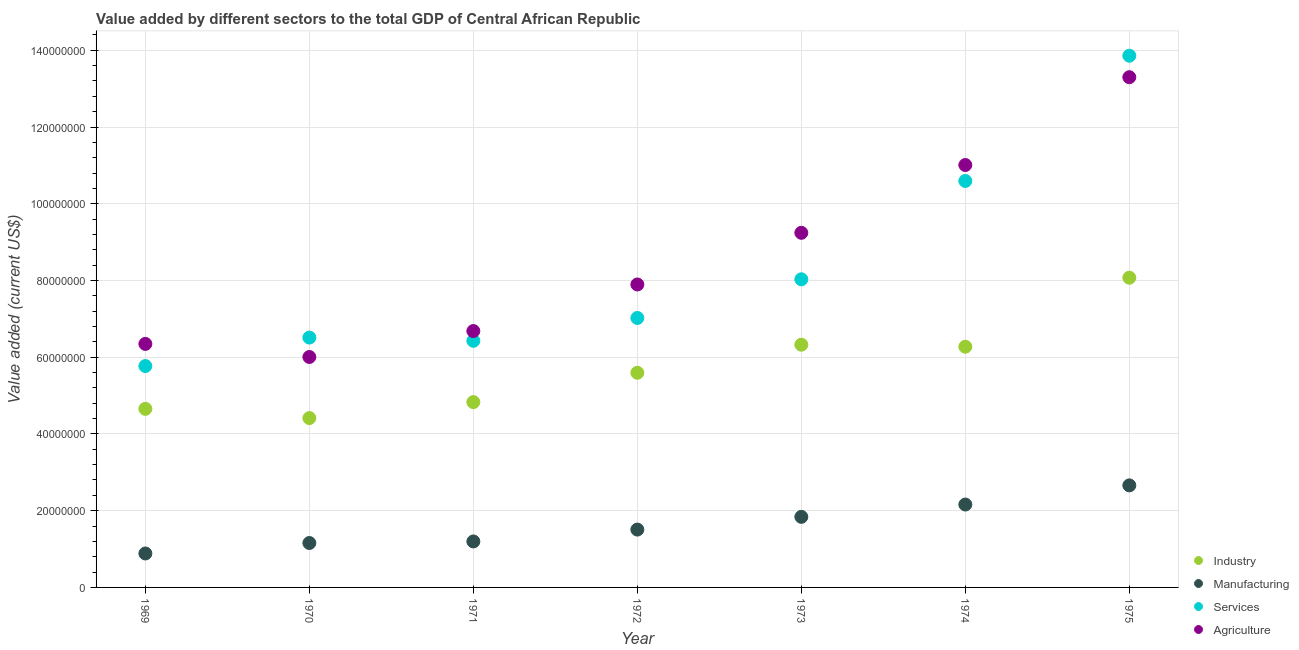How many different coloured dotlines are there?
Give a very brief answer. 4. Is the number of dotlines equal to the number of legend labels?
Ensure brevity in your answer.  Yes. What is the value added by manufacturing sector in 1969?
Your answer should be very brief. 8.85e+06. Across all years, what is the maximum value added by services sector?
Make the answer very short. 1.39e+08. Across all years, what is the minimum value added by industrial sector?
Your answer should be very brief. 4.41e+07. In which year was the value added by manufacturing sector maximum?
Offer a very short reply. 1975. In which year was the value added by services sector minimum?
Your answer should be compact. 1969. What is the total value added by agricultural sector in the graph?
Provide a short and direct response. 6.05e+08. What is the difference between the value added by services sector in 1969 and that in 1975?
Offer a terse response. -8.09e+07. What is the difference between the value added by industrial sector in 1973 and the value added by agricultural sector in 1970?
Ensure brevity in your answer.  3.20e+06. What is the average value added by services sector per year?
Provide a short and direct response. 8.32e+07. In the year 1971, what is the difference between the value added by services sector and value added by manufacturing sector?
Keep it short and to the point. 5.23e+07. In how many years, is the value added by industrial sector greater than 132000000 US$?
Ensure brevity in your answer.  0. What is the ratio of the value added by services sector in 1969 to that in 1971?
Ensure brevity in your answer.  0.9. Is the difference between the value added by agricultural sector in 1974 and 1975 greater than the difference between the value added by manufacturing sector in 1974 and 1975?
Your response must be concise. No. What is the difference between the highest and the second highest value added by manufacturing sector?
Offer a terse response. 4.99e+06. What is the difference between the highest and the lowest value added by agricultural sector?
Your answer should be compact. 7.29e+07. Is the sum of the value added by services sector in 1971 and 1972 greater than the maximum value added by industrial sector across all years?
Your answer should be compact. Yes. Is it the case that in every year, the sum of the value added by industrial sector and value added by manufacturing sector is greater than the value added by services sector?
Offer a very short reply. No. Does the value added by agricultural sector monotonically increase over the years?
Offer a terse response. No. Is the value added by industrial sector strictly greater than the value added by services sector over the years?
Your response must be concise. No. Is the value added by services sector strictly less than the value added by industrial sector over the years?
Ensure brevity in your answer.  No. What is the difference between two consecutive major ticks on the Y-axis?
Offer a very short reply. 2.00e+07. Are the values on the major ticks of Y-axis written in scientific E-notation?
Your answer should be compact. No. Does the graph contain any zero values?
Keep it short and to the point. No. How are the legend labels stacked?
Offer a very short reply. Vertical. What is the title of the graph?
Offer a terse response. Value added by different sectors to the total GDP of Central African Republic. What is the label or title of the Y-axis?
Provide a succinct answer. Value added (current US$). What is the Value added (current US$) in Industry in 1969?
Keep it short and to the point. 4.65e+07. What is the Value added (current US$) of Manufacturing in 1969?
Give a very brief answer. 8.85e+06. What is the Value added (current US$) in Services in 1969?
Give a very brief answer. 5.77e+07. What is the Value added (current US$) in Agriculture in 1969?
Make the answer very short. 6.35e+07. What is the Value added (current US$) in Industry in 1970?
Offer a terse response. 4.41e+07. What is the Value added (current US$) of Manufacturing in 1970?
Provide a short and direct response. 1.16e+07. What is the Value added (current US$) in Services in 1970?
Offer a terse response. 6.51e+07. What is the Value added (current US$) in Agriculture in 1970?
Your answer should be compact. 6.01e+07. What is the Value added (current US$) in Industry in 1971?
Your answer should be very brief. 4.83e+07. What is the Value added (current US$) in Manufacturing in 1971?
Your answer should be very brief. 1.20e+07. What is the Value added (current US$) in Services in 1971?
Provide a succinct answer. 6.43e+07. What is the Value added (current US$) of Agriculture in 1971?
Make the answer very short. 6.68e+07. What is the Value added (current US$) of Industry in 1972?
Keep it short and to the point. 5.59e+07. What is the Value added (current US$) of Manufacturing in 1972?
Make the answer very short. 1.51e+07. What is the Value added (current US$) of Services in 1972?
Provide a succinct answer. 7.02e+07. What is the Value added (current US$) in Agriculture in 1972?
Your answer should be very brief. 7.90e+07. What is the Value added (current US$) of Industry in 1973?
Make the answer very short. 6.33e+07. What is the Value added (current US$) of Manufacturing in 1973?
Offer a terse response. 1.84e+07. What is the Value added (current US$) of Services in 1973?
Your response must be concise. 8.03e+07. What is the Value added (current US$) of Agriculture in 1973?
Your answer should be compact. 9.24e+07. What is the Value added (current US$) in Industry in 1974?
Provide a short and direct response. 6.27e+07. What is the Value added (current US$) of Manufacturing in 1974?
Provide a succinct answer. 2.16e+07. What is the Value added (current US$) of Services in 1974?
Your response must be concise. 1.06e+08. What is the Value added (current US$) in Agriculture in 1974?
Your answer should be very brief. 1.10e+08. What is the Value added (current US$) of Industry in 1975?
Offer a terse response. 8.07e+07. What is the Value added (current US$) in Manufacturing in 1975?
Ensure brevity in your answer.  2.66e+07. What is the Value added (current US$) of Services in 1975?
Make the answer very short. 1.39e+08. What is the Value added (current US$) of Agriculture in 1975?
Your answer should be compact. 1.33e+08. Across all years, what is the maximum Value added (current US$) in Industry?
Offer a terse response. 8.07e+07. Across all years, what is the maximum Value added (current US$) of Manufacturing?
Provide a short and direct response. 2.66e+07. Across all years, what is the maximum Value added (current US$) of Services?
Offer a terse response. 1.39e+08. Across all years, what is the maximum Value added (current US$) in Agriculture?
Provide a succinct answer. 1.33e+08. Across all years, what is the minimum Value added (current US$) of Industry?
Provide a short and direct response. 4.41e+07. Across all years, what is the minimum Value added (current US$) of Manufacturing?
Provide a succinct answer. 8.85e+06. Across all years, what is the minimum Value added (current US$) in Services?
Offer a terse response. 5.77e+07. Across all years, what is the minimum Value added (current US$) of Agriculture?
Your answer should be compact. 6.01e+07. What is the total Value added (current US$) in Industry in the graph?
Give a very brief answer. 4.02e+08. What is the total Value added (current US$) in Manufacturing in the graph?
Provide a short and direct response. 1.14e+08. What is the total Value added (current US$) in Services in the graph?
Make the answer very short. 5.82e+08. What is the total Value added (current US$) in Agriculture in the graph?
Your answer should be very brief. 6.05e+08. What is the difference between the Value added (current US$) in Industry in 1969 and that in 1970?
Your response must be concise. 2.41e+06. What is the difference between the Value added (current US$) of Manufacturing in 1969 and that in 1970?
Your answer should be very brief. -2.73e+06. What is the difference between the Value added (current US$) in Services in 1969 and that in 1970?
Your answer should be compact. -7.42e+06. What is the difference between the Value added (current US$) of Agriculture in 1969 and that in 1970?
Keep it short and to the point. 3.41e+06. What is the difference between the Value added (current US$) of Industry in 1969 and that in 1971?
Give a very brief answer. -1.76e+06. What is the difference between the Value added (current US$) in Manufacturing in 1969 and that in 1971?
Offer a terse response. -3.14e+06. What is the difference between the Value added (current US$) in Services in 1969 and that in 1971?
Offer a terse response. -6.58e+06. What is the difference between the Value added (current US$) of Agriculture in 1969 and that in 1971?
Your answer should be compact. -3.35e+06. What is the difference between the Value added (current US$) in Industry in 1969 and that in 1972?
Make the answer very short. -9.40e+06. What is the difference between the Value added (current US$) of Manufacturing in 1969 and that in 1972?
Your answer should be very brief. -6.23e+06. What is the difference between the Value added (current US$) of Services in 1969 and that in 1972?
Your response must be concise. -1.25e+07. What is the difference between the Value added (current US$) in Agriculture in 1969 and that in 1972?
Make the answer very short. -1.55e+07. What is the difference between the Value added (current US$) in Industry in 1969 and that in 1973?
Offer a very short reply. -1.67e+07. What is the difference between the Value added (current US$) in Manufacturing in 1969 and that in 1973?
Your answer should be compact. -9.55e+06. What is the difference between the Value added (current US$) of Services in 1969 and that in 1973?
Keep it short and to the point. -2.26e+07. What is the difference between the Value added (current US$) of Agriculture in 1969 and that in 1973?
Your answer should be very brief. -2.90e+07. What is the difference between the Value added (current US$) in Industry in 1969 and that in 1974?
Keep it short and to the point. -1.62e+07. What is the difference between the Value added (current US$) of Manufacturing in 1969 and that in 1974?
Keep it short and to the point. -1.28e+07. What is the difference between the Value added (current US$) of Services in 1969 and that in 1974?
Provide a succinct answer. -4.82e+07. What is the difference between the Value added (current US$) in Agriculture in 1969 and that in 1974?
Provide a succinct answer. -4.66e+07. What is the difference between the Value added (current US$) of Industry in 1969 and that in 1975?
Give a very brief answer. -3.42e+07. What is the difference between the Value added (current US$) of Manufacturing in 1969 and that in 1975?
Ensure brevity in your answer.  -1.77e+07. What is the difference between the Value added (current US$) of Services in 1969 and that in 1975?
Your response must be concise. -8.09e+07. What is the difference between the Value added (current US$) in Agriculture in 1969 and that in 1975?
Offer a terse response. -6.95e+07. What is the difference between the Value added (current US$) in Industry in 1970 and that in 1971?
Provide a short and direct response. -4.16e+06. What is the difference between the Value added (current US$) in Manufacturing in 1970 and that in 1971?
Provide a succinct answer. -4.07e+05. What is the difference between the Value added (current US$) in Services in 1970 and that in 1971?
Your response must be concise. 8.42e+05. What is the difference between the Value added (current US$) of Agriculture in 1970 and that in 1971?
Make the answer very short. -6.77e+06. What is the difference between the Value added (current US$) in Industry in 1970 and that in 1972?
Your answer should be very brief. -1.18e+07. What is the difference between the Value added (current US$) in Manufacturing in 1970 and that in 1972?
Offer a very short reply. -3.50e+06. What is the difference between the Value added (current US$) in Services in 1970 and that in 1972?
Offer a very short reply. -5.11e+06. What is the difference between the Value added (current US$) of Agriculture in 1970 and that in 1972?
Your answer should be compact. -1.89e+07. What is the difference between the Value added (current US$) in Industry in 1970 and that in 1973?
Give a very brief answer. -1.91e+07. What is the difference between the Value added (current US$) in Manufacturing in 1970 and that in 1973?
Your answer should be very brief. -6.82e+06. What is the difference between the Value added (current US$) in Services in 1970 and that in 1973?
Keep it short and to the point. -1.52e+07. What is the difference between the Value added (current US$) in Agriculture in 1970 and that in 1973?
Provide a short and direct response. -3.24e+07. What is the difference between the Value added (current US$) of Industry in 1970 and that in 1974?
Keep it short and to the point. -1.86e+07. What is the difference between the Value added (current US$) of Manufacturing in 1970 and that in 1974?
Your response must be concise. -1.00e+07. What is the difference between the Value added (current US$) of Services in 1970 and that in 1974?
Give a very brief answer. -4.08e+07. What is the difference between the Value added (current US$) in Agriculture in 1970 and that in 1974?
Offer a terse response. -5.00e+07. What is the difference between the Value added (current US$) in Industry in 1970 and that in 1975?
Ensure brevity in your answer.  -3.66e+07. What is the difference between the Value added (current US$) in Manufacturing in 1970 and that in 1975?
Provide a short and direct response. -1.50e+07. What is the difference between the Value added (current US$) of Services in 1970 and that in 1975?
Give a very brief answer. -7.35e+07. What is the difference between the Value added (current US$) of Agriculture in 1970 and that in 1975?
Offer a very short reply. -7.29e+07. What is the difference between the Value added (current US$) of Industry in 1971 and that in 1972?
Your answer should be very brief. -7.65e+06. What is the difference between the Value added (current US$) in Manufacturing in 1971 and that in 1972?
Offer a terse response. -3.09e+06. What is the difference between the Value added (current US$) of Services in 1971 and that in 1972?
Make the answer very short. -5.95e+06. What is the difference between the Value added (current US$) of Agriculture in 1971 and that in 1972?
Ensure brevity in your answer.  -1.21e+07. What is the difference between the Value added (current US$) of Industry in 1971 and that in 1973?
Provide a short and direct response. -1.50e+07. What is the difference between the Value added (current US$) of Manufacturing in 1971 and that in 1973?
Give a very brief answer. -6.41e+06. What is the difference between the Value added (current US$) in Services in 1971 and that in 1973?
Offer a terse response. -1.60e+07. What is the difference between the Value added (current US$) of Agriculture in 1971 and that in 1973?
Offer a terse response. -2.56e+07. What is the difference between the Value added (current US$) of Industry in 1971 and that in 1974?
Offer a terse response. -1.44e+07. What is the difference between the Value added (current US$) in Manufacturing in 1971 and that in 1974?
Your answer should be very brief. -9.62e+06. What is the difference between the Value added (current US$) of Services in 1971 and that in 1974?
Make the answer very short. -4.17e+07. What is the difference between the Value added (current US$) of Agriculture in 1971 and that in 1974?
Your response must be concise. -4.33e+07. What is the difference between the Value added (current US$) in Industry in 1971 and that in 1975?
Make the answer very short. -3.24e+07. What is the difference between the Value added (current US$) in Manufacturing in 1971 and that in 1975?
Your answer should be compact. -1.46e+07. What is the difference between the Value added (current US$) of Services in 1971 and that in 1975?
Your response must be concise. -7.43e+07. What is the difference between the Value added (current US$) of Agriculture in 1971 and that in 1975?
Offer a very short reply. -6.62e+07. What is the difference between the Value added (current US$) in Industry in 1972 and that in 1973?
Make the answer very short. -7.31e+06. What is the difference between the Value added (current US$) of Manufacturing in 1972 and that in 1973?
Give a very brief answer. -3.32e+06. What is the difference between the Value added (current US$) of Services in 1972 and that in 1973?
Make the answer very short. -1.01e+07. What is the difference between the Value added (current US$) in Agriculture in 1972 and that in 1973?
Provide a succinct answer. -1.35e+07. What is the difference between the Value added (current US$) of Industry in 1972 and that in 1974?
Offer a terse response. -6.79e+06. What is the difference between the Value added (current US$) of Manufacturing in 1972 and that in 1974?
Give a very brief answer. -6.53e+06. What is the difference between the Value added (current US$) of Services in 1972 and that in 1974?
Keep it short and to the point. -3.57e+07. What is the difference between the Value added (current US$) of Agriculture in 1972 and that in 1974?
Provide a succinct answer. -3.11e+07. What is the difference between the Value added (current US$) in Industry in 1972 and that in 1975?
Your answer should be compact. -2.48e+07. What is the difference between the Value added (current US$) of Manufacturing in 1972 and that in 1975?
Ensure brevity in your answer.  -1.15e+07. What is the difference between the Value added (current US$) in Services in 1972 and that in 1975?
Give a very brief answer. -6.84e+07. What is the difference between the Value added (current US$) in Agriculture in 1972 and that in 1975?
Give a very brief answer. -5.40e+07. What is the difference between the Value added (current US$) in Industry in 1973 and that in 1974?
Your response must be concise. 5.28e+05. What is the difference between the Value added (current US$) in Manufacturing in 1973 and that in 1974?
Make the answer very short. -3.21e+06. What is the difference between the Value added (current US$) in Services in 1973 and that in 1974?
Your response must be concise. -2.56e+07. What is the difference between the Value added (current US$) of Agriculture in 1973 and that in 1974?
Make the answer very short. -1.77e+07. What is the difference between the Value added (current US$) of Industry in 1973 and that in 1975?
Your answer should be very brief. -1.75e+07. What is the difference between the Value added (current US$) of Manufacturing in 1973 and that in 1975?
Give a very brief answer. -8.20e+06. What is the difference between the Value added (current US$) in Services in 1973 and that in 1975?
Offer a terse response. -5.83e+07. What is the difference between the Value added (current US$) in Agriculture in 1973 and that in 1975?
Offer a very short reply. -4.06e+07. What is the difference between the Value added (current US$) in Industry in 1974 and that in 1975?
Provide a short and direct response. -1.80e+07. What is the difference between the Value added (current US$) of Manufacturing in 1974 and that in 1975?
Provide a short and direct response. -4.99e+06. What is the difference between the Value added (current US$) of Services in 1974 and that in 1975?
Provide a short and direct response. -3.26e+07. What is the difference between the Value added (current US$) in Agriculture in 1974 and that in 1975?
Your answer should be very brief. -2.29e+07. What is the difference between the Value added (current US$) in Industry in 1969 and the Value added (current US$) in Manufacturing in 1970?
Provide a succinct answer. 3.50e+07. What is the difference between the Value added (current US$) in Industry in 1969 and the Value added (current US$) in Services in 1970?
Provide a succinct answer. -1.86e+07. What is the difference between the Value added (current US$) in Industry in 1969 and the Value added (current US$) in Agriculture in 1970?
Offer a terse response. -1.35e+07. What is the difference between the Value added (current US$) of Manufacturing in 1969 and the Value added (current US$) of Services in 1970?
Your response must be concise. -5.63e+07. What is the difference between the Value added (current US$) of Manufacturing in 1969 and the Value added (current US$) of Agriculture in 1970?
Ensure brevity in your answer.  -5.12e+07. What is the difference between the Value added (current US$) in Services in 1969 and the Value added (current US$) in Agriculture in 1970?
Your answer should be compact. -2.36e+06. What is the difference between the Value added (current US$) of Industry in 1969 and the Value added (current US$) of Manufacturing in 1971?
Offer a very short reply. 3.46e+07. What is the difference between the Value added (current US$) of Industry in 1969 and the Value added (current US$) of Services in 1971?
Provide a short and direct response. -1.77e+07. What is the difference between the Value added (current US$) in Industry in 1969 and the Value added (current US$) in Agriculture in 1971?
Make the answer very short. -2.03e+07. What is the difference between the Value added (current US$) in Manufacturing in 1969 and the Value added (current US$) in Services in 1971?
Give a very brief answer. -5.54e+07. What is the difference between the Value added (current US$) of Manufacturing in 1969 and the Value added (current US$) of Agriculture in 1971?
Your answer should be very brief. -5.80e+07. What is the difference between the Value added (current US$) in Services in 1969 and the Value added (current US$) in Agriculture in 1971?
Provide a short and direct response. -9.12e+06. What is the difference between the Value added (current US$) of Industry in 1969 and the Value added (current US$) of Manufacturing in 1972?
Offer a terse response. 3.15e+07. What is the difference between the Value added (current US$) of Industry in 1969 and the Value added (current US$) of Services in 1972?
Your response must be concise. -2.37e+07. What is the difference between the Value added (current US$) of Industry in 1969 and the Value added (current US$) of Agriculture in 1972?
Keep it short and to the point. -3.24e+07. What is the difference between the Value added (current US$) in Manufacturing in 1969 and the Value added (current US$) in Services in 1972?
Make the answer very short. -6.14e+07. What is the difference between the Value added (current US$) in Manufacturing in 1969 and the Value added (current US$) in Agriculture in 1972?
Your response must be concise. -7.01e+07. What is the difference between the Value added (current US$) of Services in 1969 and the Value added (current US$) of Agriculture in 1972?
Your answer should be compact. -2.13e+07. What is the difference between the Value added (current US$) of Industry in 1969 and the Value added (current US$) of Manufacturing in 1973?
Your answer should be very brief. 2.82e+07. What is the difference between the Value added (current US$) of Industry in 1969 and the Value added (current US$) of Services in 1973?
Keep it short and to the point. -3.38e+07. What is the difference between the Value added (current US$) in Industry in 1969 and the Value added (current US$) in Agriculture in 1973?
Give a very brief answer. -4.59e+07. What is the difference between the Value added (current US$) in Manufacturing in 1969 and the Value added (current US$) in Services in 1973?
Make the answer very short. -7.15e+07. What is the difference between the Value added (current US$) of Manufacturing in 1969 and the Value added (current US$) of Agriculture in 1973?
Offer a terse response. -8.36e+07. What is the difference between the Value added (current US$) of Services in 1969 and the Value added (current US$) of Agriculture in 1973?
Your response must be concise. -3.47e+07. What is the difference between the Value added (current US$) in Industry in 1969 and the Value added (current US$) in Manufacturing in 1974?
Keep it short and to the point. 2.49e+07. What is the difference between the Value added (current US$) in Industry in 1969 and the Value added (current US$) in Services in 1974?
Make the answer very short. -5.94e+07. What is the difference between the Value added (current US$) in Industry in 1969 and the Value added (current US$) in Agriculture in 1974?
Make the answer very short. -6.35e+07. What is the difference between the Value added (current US$) in Manufacturing in 1969 and the Value added (current US$) in Services in 1974?
Keep it short and to the point. -9.71e+07. What is the difference between the Value added (current US$) in Manufacturing in 1969 and the Value added (current US$) in Agriculture in 1974?
Offer a very short reply. -1.01e+08. What is the difference between the Value added (current US$) in Services in 1969 and the Value added (current US$) in Agriculture in 1974?
Make the answer very short. -5.24e+07. What is the difference between the Value added (current US$) in Industry in 1969 and the Value added (current US$) in Manufacturing in 1975?
Offer a terse response. 1.99e+07. What is the difference between the Value added (current US$) in Industry in 1969 and the Value added (current US$) in Services in 1975?
Make the answer very short. -9.20e+07. What is the difference between the Value added (current US$) of Industry in 1969 and the Value added (current US$) of Agriculture in 1975?
Your answer should be compact. -8.64e+07. What is the difference between the Value added (current US$) in Manufacturing in 1969 and the Value added (current US$) in Services in 1975?
Ensure brevity in your answer.  -1.30e+08. What is the difference between the Value added (current US$) of Manufacturing in 1969 and the Value added (current US$) of Agriculture in 1975?
Ensure brevity in your answer.  -1.24e+08. What is the difference between the Value added (current US$) of Services in 1969 and the Value added (current US$) of Agriculture in 1975?
Your answer should be very brief. -7.53e+07. What is the difference between the Value added (current US$) of Industry in 1970 and the Value added (current US$) of Manufacturing in 1971?
Keep it short and to the point. 3.22e+07. What is the difference between the Value added (current US$) in Industry in 1970 and the Value added (current US$) in Services in 1971?
Give a very brief answer. -2.01e+07. What is the difference between the Value added (current US$) of Industry in 1970 and the Value added (current US$) of Agriculture in 1971?
Give a very brief answer. -2.27e+07. What is the difference between the Value added (current US$) of Manufacturing in 1970 and the Value added (current US$) of Services in 1971?
Ensure brevity in your answer.  -5.27e+07. What is the difference between the Value added (current US$) in Manufacturing in 1970 and the Value added (current US$) in Agriculture in 1971?
Make the answer very short. -5.52e+07. What is the difference between the Value added (current US$) of Services in 1970 and the Value added (current US$) of Agriculture in 1971?
Keep it short and to the point. -1.70e+06. What is the difference between the Value added (current US$) in Industry in 1970 and the Value added (current US$) in Manufacturing in 1972?
Provide a succinct answer. 2.91e+07. What is the difference between the Value added (current US$) in Industry in 1970 and the Value added (current US$) in Services in 1972?
Your answer should be compact. -2.61e+07. What is the difference between the Value added (current US$) in Industry in 1970 and the Value added (current US$) in Agriculture in 1972?
Your answer should be compact. -3.48e+07. What is the difference between the Value added (current US$) of Manufacturing in 1970 and the Value added (current US$) of Services in 1972?
Your response must be concise. -5.87e+07. What is the difference between the Value added (current US$) of Manufacturing in 1970 and the Value added (current US$) of Agriculture in 1972?
Keep it short and to the point. -6.74e+07. What is the difference between the Value added (current US$) in Services in 1970 and the Value added (current US$) in Agriculture in 1972?
Provide a succinct answer. -1.38e+07. What is the difference between the Value added (current US$) in Industry in 1970 and the Value added (current US$) in Manufacturing in 1973?
Keep it short and to the point. 2.57e+07. What is the difference between the Value added (current US$) of Industry in 1970 and the Value added (current US$) of Services in 1973?
Your answer should be very brief. -3.62e+07. What is the difference between the Value added (current US$) of Industry in 1970 and the Value added (current US$) of Agriculture in 1973?
Offer a very short reply. -4.83e+07. What is the difference between the Value added (current US$) in Manufacturing in 1970 and the Value added (current US$) in Services in 1973?
Offer a terse response. -6.87e+07. What is the difference between the Value added (current US$) of Manufacturing in 1970 and the Value added (current US$) of Agriculture in 1973?
Provide a short and direct response. -8.08e+07. What is the difference between the Value added (current US$) in Services in 1970 and the Value added (current US$) in Agriculture in 1973?
Provide a short and direct response. -2.73e+07. What is the difference between the Value added (current US$) of Industry in 1970 and the Value added (current US$) of Manufacturing in 1974?
Offer a very short reply. 2.25e+07. What is the difference between the Value added (current US$) in Industry in 1970 and the Value added (current US$) in Services in 1974?
Your answer should be compact. -6.18e+07. What is the difference between the Value added (current US$) in Industry in 1970 and the Value added (current US$) in Agriculture in 1974?
Your answer should be compact. -6.60e+07. What is the difference between the Value added (current US$) of Manufacturing in 1970 and the Value added (current US$) of Services in 1974?
Keep it short and to the point. -9.44e+07. What is the difference between the Value added (current US$) of Manufacturing in 1970 and the Value added (current US$) of Agriculture in 1974?
Give a very brief answer. -9.85e+07. What is the difference between the Value added (current US$) in Services in 1970 and the Value added (current US$) in Agriculture in 1974?
Keep it short and to the point. -4.50e+07. What is the difference between the Value added (current US$) in Industry in 1970 and the Value added (current US$) in Manufacturing in 1975?
Provide a succinct answer. 1.75e+07. What is the difference between the Value added (current US$) in Industry in 1970 and the Value added (current US$) in Services in 1975?
Offer a terse response. -9.44e+07. What is the difference between the Value added (current US$) in Industry in 1970 and the Value added (current US$) in Agriculture in 1975?
Offer a very short reply. -8.88e+07. What is the difference between the Value added (current US$) of Manufacturing in 1970 and the Value added (current US$) of Services in 1975?
Ensure brevity in your answer.  -1.27e+08. What is the difference between the Value added (current US$) in Manufacturing in 1970 and the Value added (current US$) in Agriculture in 1975?
Your response must be concise. -1.21e+08. What is the difference between the Value added (current US$) of Services in 1970 and the Value added (current US$) of Agriculture in 1975?
Ensure brevity in your answer.  -6.79e+07. What is the difference between the Value added (current US$) in Industry in 1971 and the Value added (current US$) in Manufacturing in 1972?
Your answer should be very brief. 3.32e+07. What is the difference between the Value added (current US$) in Industry in 1971 and the Value added (current US$) in Services in 1972?
Provide a succinct answer. -2.19e+07. What is the difference between the Value added (current US$) in Industry in 1971 and the Value added (current US$) in Agriculture in 1972?
Your answer should be very brief. -3.07e+07. What is the difference between the Value added (current US$) in Manufacturing in 1971 and the Value added (current US$) in Services in 1972?
Your answer should be very brief. -5.82e+07. What is the difference between the Value added (current US$) in Manufacturing in 1971 and the Value added (current US$) in Agriculture in 1972?
Make the answer very short. -6.70e+07. What is the difference between the Value added (current US$) in Services in 1971 and the Value added (current US$) in Agriculture in 1972?
Your answer should be very brief. -1.47e+07. What is the difference between the Value added (current US$) in Industry in 1971 and the Value added (current US$) in Manufacturing in 1973?
Offer a terse response. 2.99e+07. What is the difference between the Value added (current US$) of Industry in 1971 and the Value added (current US$) of Services in 1973?
Offer a very short reply. -3.20e+07. What is the difference between the Value added (current US$) in Industry in 1971 and the Value added (current US$) in Agriculture in 1973?
Your response must be concise. -4.41e+07. What is the difference between the Value added (current US$) in Manufacturing in 1971 and the Value added (current US$) in Services in 1973?
Make the answer very short. -6.83e+07. What is the difference between the Value added (current US$) in Manufacturing in 1971 and the Value added (current US$) in Agriculture in 1973?
Your answer should be very brief. -8.04e+07. What is the difference between the Value added (current US$) of Services in 1971 and the Value added (current US$) of Agriculture in 1973?
Your answer should be compact. -2.81e+07. What is the difference between the Value added (current US$) of Industry in 1971 and the Value added (current US$) of Manufacturing in 1974?
Your response must be concise. 2.67e+07. What is the difference between the Value added (current US$) in Industry in 1971 and the Value added (current US$) in Services in 1974?
Your answer should be compact. -5.76e+07. What is the difference between the Value added (current US$) of Industry in 1971 and the Value added (current US$) of Agriculture in 1974?
Your response must be concise. -6.18e+07. What is the difference between the Value added (current US$) of Manufacturing in 1971 and the Value added (current US$) of Services in 1974?
Give a very brief answer. -9.40e+07. What is the difference between the Value added (current US$) of Manufacturing in 1971 and the Value added (current US$) of Agriculture in 1974?
Keep it short and to the point. -9.81e+07. What is the difference between the Value added (current US$) of Services in 1971 and the Value added (current US$) of Agriculture in 1974?
Provide a succinct answer. -4.58e+07. What is the difference between the Value added (current US$) in Industry in 1971 and the Value added (current US$) in Manufacturing in 1975?
Your response must be concise. 2.17e+07. What is the difference between the Value added (current US$) of Industry in 1971 and the Value added (current US$) of Services in 1975?
Your response must be concise. -9.03e+07. What is the difference between the Value added (current US$) of Industry in 1971 and the Value added (current US$) of Agriculture in 1975?
Offer a terse response. -8.47e+07. What is the difference between the Value added (current US$) in Manufacturing in 1971 and the Value added (current US$) in Services in 1975?
Provide a short and direct response. -1.27e+08. What is the difference between the Value added (current US$) in Manufacturing in 1971 and the Value added (current US$) in Agriculture in 1975?
Keep it short and to the point. -1.21e+08. What is the difference between the Value added (current US$) in Services in 1971 and the Value added (current US$) in Agriculture in 1975?
Your response must be concise. -6.87e+07. What is the difference between the Value added (current US$) in Industry in 1972 and the Value added (current US$) in Manufacturing in 1973?
Offer a very short reply. 3.76e+07. What is the difference between the Value added (current US$) in Industry in 1972 and the Value added (current US$) in Services in 1973?
Your answer should be very brief. -2.44e+07. What is the difference between the Value added (current US$) in Industry in 1972 and the Value added (current US$) in Agriculture in 1973?
Give a very brief answer. -3.65e+07. What is the difference between the Value added (current US$) in Manufacturing in 1972 and the Value added (current US$) in Services in 1973?
Give a very brief answer. -6.52e+07. What is the difference between the Value added (current US$) in Manufacturing in 1972 and the Value added (current US$) in Agriculture in 1973?
Your answer should be very brief. -7.73e+07. What is the difference between the Value added (current US$) in Services in 1972 and the Value added (current US$) in Agriculture in 1973?
Keep it short and to the point. -2.22e+07. What is the difference between the Value added (current US$) of Industry in 1972 and the Value added (current US$) of Manufacturing in 1974?
Your response must be concise. 3.43e+07. What is the difference between the Value added (current US$) in Industry in 1972 and the Value added (current US$) in Services in 1974?
Your answer should be compact. -5.00e+07. What is the difference between the Value added (current US$) in Industry in 1972 and the Value added (current US$) in Agriculture in 1974?
Your response must be concise. -5.41e+07. What is the difference between the Value added (current US$) of Manufacturing in 1972 and the Value added (current US$) of Services in 1974?
Make the answer very short. -9.09e+07. What is the difference between the Value added (current US$) of Manufacturing in 1972 and the Value added (current US$) of Agriculture in 1974?
Offer a very short reply. -9.50e+07. What is the difference between the Value added (current US$) in Services in 1972 and the Value added (current US$) in Agriculture in 1974?
Make the answer very short. -3.99e+07. What is the difference between the Value added (current US$) in Industry in 1972 and the Value added (current US$) in Manufacturing in 1975?
Ensure brevity in your answer.  2.93e+07. What is the difference between the Value added (current US$) in Industry in 1972 and the Value added (current US$) in Services in 1975?
Offer a terse response. -8.26e+07. What is the difference between the Value added (current US$) in Industry in 1972 and the Value added (current US$) in Agriculture in 1975?
Make the answer very short. -7.70e+07. What is the difference between the Value added (current US$) in Manufacturing in 1972 and the Value added (current US$) in Services in 1975?
Your answer should be compact. -1.24e+08. What is the difference between the Value added (current US$) of Manufacturing in 1972 and the Value added (current US$) of Agriculture in 1975?
Your answer should be compact. -1.18e+08. What is the difference between the Value added (current US$) of Services in 1972 and the Value added (current US$) of Agriculture in 1975?
Offer a very short reply. -6.28e+07. What is the difference between the Value added (current US$) in Industry in 1973 and the Value added (current US$) in Manufacturing in 1974?
Make the answer very short. 4.17e+07. What is the difference between the Value added (current US$) of Industry in 1973 and the Value added (current US$) of Services in 1974?
Keep it short and to the point. -4.27e+07. What is the difference between the Value added (current US$) in Industry in 1973 and the Value added (current US$) in Agriculture in 1974?
Give a very brief answer. -4.68e+07. What is the difference between the Value added (current US$) of Manufacturing in 1973 and the Value added (current US$) of Services in 1974?
Your answer should be compact. -8.75e+07. What is the difference between the Value added (current US$) in Manufacturing in 1973 and the Value added (current US$) in Agriculture in 1974?
Provide a short and direct response. -9.17e+07. What is the difference between the Value added (current US$) of Services in 1973 and the Value added (current US$) of Agriculture in 1974?
Provide a short and direct response. -2.98e+07. What is the difference between the Value added (current US$) of Industry in 1973 and the Value added (current US$) of Manufacturing in 1975?
Your answer should be compact. 3.67e+07. What is the difference between the Value added (current US$) in Industry in 1973 and the Value added (current US$) in Services in 1975?
Your response must be concise. -7.53e+07. What is the difference between the Value added (current US$) in Industry in 1973 and the Value added (current US$) in Agriculture in 1975?
Your response must be concise. -6.97e+07. What is the difference between the Value added (current US$) in Manufacturing in 1973 and the Value added (current US$) in Services in 1975?
Offer a terse response. -1.20e+08. What is the difference between the Value added (current US$) in Manufacturing in 1973 and the Value added (current US$) in Agriculture in 1975?
Offer a terse response. -1.15e+08. What is the difference between the Value added (current US$) of Services in 1973 and the Value added (current US$) of Agriculture in 1975?
Ensure brevity in your answer.  -5.27e+07. What is the difference between the Value added (current US$) in Industry in 1974 and the Value added (current US$) in Manufacturing in 1975?
Your answer should be very brief. 3.61e+07. What is the difference between the Value added (current US$) in Industry in 1974 and the Value added (current US$) in Services in 1975?
Offer a terse response. -7.58e+07. What is the difference between the Value added (current US$) in Industry in 1974 and the Value added (current US$) in Agriculture in 1975?
Your response must be concise. -7.03e+07. What is the difference between the Value added (current US$) of Manufacturing in 1974 and the Value added (current US$) of Services in 1975?
Your answer should be very brief. -1.17e+08. What is the difference between the Value added (current US$) in Manufacturing in 1974 and the Value added (current US$) in Agriculture in 1975?
Ensure brevity in your answer.  -1.11e+08. What is the difference between the Value added (current US$) in Services in 1974 and the Value added (current US$) in Agriculture in 1975?
Provide a succinct answer. -2.70e+07. What is the average Value added (current US$) in Industry per year?
Provide a succinct answer. 5.74e+07. What is the average Value added (current US$) of Manufacturing per year?
Give a very brief answer. 1.63e+07. What is the average Value added (current US$) in Services per year?
Your answer should be compact. 8.32e+07. What is the average Value added (current US$) of Agriculture per year?
Keep it short and to the point. 8.64e+07. In the year 1969, what is the difference between the Value added (current US$) of Industry and Value added (current US$) of Manufacturing?
Your response must be concise. 3.77e+07. In the year 1969, what is the difference between the Value added (current US$) of Industry and Value added (current US$) of Services?
Give a very brief answer. -1.12e+07. In the year 1969, what is the difference between the Value added (current US$) of Industry and Value added (current US$) of Agriculture?
Offer a terse response. -1.69e+07. In the year 1969, what is the difference between the Value added (current US$) of Manufacturing and Value added (current US$) of Services?
Offer a terse response. -4.89e+07. In the year 1969, what is the difference between the Value added (current US$) in Manufacturing and Value added (current US$) in Agriculture?
Make the answer very short. -5.46e+07. In the year 1969, what is the difference between the Value added (current US$) in Services and Value added (current US$) in Agriculture?
Make the answer very short. -5.77e+06. In the year 1970, what is the difference between the Value added (current US$) in Industry and Value added (current US$) in Manufacturing?
Your answer should be very brief. 3.26e+07. In the year 1970, what is the difference between the Value added (current US$) in Industry and Value added (current US$) in Services?
Provide a short and direct response. -2.10e+07. In the year 1970, what is the difference between the Value added (current US$) of Industry and Value added (current US$) of Agriculture?
Provide a short and direct response. -1.59e+07. In the year 1970, what is the difference between the Value added (current US$) of Manufacturing and Value added (current US$) of Services?
Your response must be concise. -5.35e+07. In the year 1970, what is the difference between the Value added (current US$) in Manufacturing and Value added (current US$) in Agriculture?
Give a very brief answer. -4.85e+07. In the year 1970, what is the difference between the Value added (current US$) of Services and Value added (current US$) of Agriculture?
Make the answer very short. 5.06e+06. In the year 1971, what is the difference between the Value added (current US$) of Industry and Value added (current US$) of Manufacturing?
Offer a terse response. 3.63e+07. In the year 1971, what is the difference between the Value added (current US$) of Industry and Value added (current US$) of Services?
Give a very brief answer. -1.60e+07. In the year 1971, what is the difference between the Value added (current US$) of Industry and Value added (current US$) of Agriculture?
Provide a succinct answer. -1.85e+07. In the year 1971, what is the difference between the Value added (current US$) in Manufacturing and Value added (current US$) in Services?
Make the answer very short. -5.23e+07. In the year 1971, what is the difference between the Value added (current US$) in Manufacturing and Value added (current US$) in Agriculture?
Provide a short and direct response. -5.48e+07. In the year 1971, what is the difference between the Value added (current US$) of Services and Value added (current US$) of Agriculture?
Keep it short and to the point. -2.54e+06. In the year 1972, what is the difference between the Value added (current US$) of Industry and Value added (current US$) of Manufacturing?
Ensure brevity in your answer.  4.09e+07. In the year 1972, what is the difference between the Value added (current US$) of Industry and Value added (current US$) of Services?
Your response must be concise. -1.43e+07. In the year 1972, what is the difference between the Value added (current US$) in Industry and Value added (current US$) in Agriculture?
Offer a terse response. -2.30e+07. In the year 1972, what is the difference between the Value added (current US$) in Manufacturing and Value added (current US$) in Services?
Make the answer very short. -5.52e+07. In the year 1972, what is the difference between the Value added (current US$) of Manufacturing and Value added (current US$) of Agriculture?
Your answer should be very brief. -6.39e+07. In the year 1972, what is the difference between the Value added (current US$) in Services and Value added (current US$) in Agriculture?
Offer a very short reply. -8.73e+06. In the year 1973, what is the difference between the Value added (current US$) of Industry and Value added (current US$) of Manufacturing?
Your response must be concise. 4.49e+07. In the year 1973, what is the difference between the Value added (current US$) of Industry and Value added (current US$) of Services?
Offer a terse response. -1.70e+07. In the year 1973, what is the difference between the Value added (current US$) in Industry and Value added (current US$) in Agriculture?
Provide a succinct answer. -2.92e+07. In the year 1973, what is the difference between the Value added (current US$) of Manufacturing and Value added (current US$) of Services?
Offer a very short reply. -6.19e+07. In the year 1973, what is the difference between the Value added (current US$) of Manufacturing and Value added (current US$) of Agriculture?
Provide a succinct answer. -7.40e+07. In the year 1973, what is the difference between the Value added (current US$) of Services and Value added (current US$) of Agriculture?
Your answer should be very brief. -1.21e+07. In the year 1974, what is the difference between the Value added (current US$) in Industry and Value added (current US$) in Manufacturing?
Your response must be concise. 4.11e+07. In the year 1974, what is the difference between the Value added (current US$) in Industry and Value added (current US$) in Services?
Make the answer very short. -4.32e+07. In the year 1974, what is the difference between the Value added (current US$) of Industry and Value added (current US$) of Agriculture?
Your response must be concise. -4.74e+07. In the year 1974, what is the difference between the Value added (current US$) in Manufacturing and Value added (current US$) in Services?
Offer a very short reply. -8.43e+07. In the year 1974, what is the difference between the Value added (current US$) of Manufacturing and Value added (current US$) of Agriculture?
Offer a very short reply. -8.85e+07. In the year 1974, what is the difference between the Value added (current US$) in Services and Value added (current US$) in Agriculture?
Your answer should be very brief. -4.15e+06. In the year 1975, what is the difference between the Value added (current US$) in Industry and Value added (current US$) in Manufacturing?
Give a very brief answer. 5.41e+07. In the year 1975, what is the difference between the Value added (current US$) in Industry and Value added (current US$) in Services?
Make the answer very short. -5.79e+07. In the year 1975, what is the difference between the Value added (current US$) of Industry and Value added (current US$) of Agriculture?
Make the answer very short. -5.23e+07. In the year 1975, what is the difference between the Value added (current US$) in Manufacturing and Value added (current US$) in Services?
Offer a terse response. -1.12e+08. In the year 1975, what is the difference between the Value added (current US$) of Manufacturing and Value added (current US$) of Agriculture?
Provide a short and direct response. -1.06e+08. In the year 1975, what is the difference between the Value added (current US$) in Services and Value added (current US$) in Agriculture?
Keep it short and to the point. 5.60e+06. What is the ratio of the Value added (current US$) in Industry in 1969 to that in 1970?
Offer a very short reply. 1.05. What is the ratio of the Value added (current US$) of Manufacturing in 1969 to that in 1970?
Provide a short and direct response. 0.76. What is the ratio of the Value added (current US$) in Services in 1969 to that in 1970?
Ensure brevity in your answer.  0.89. What is the ratio of the Value added (current US$) in Agriculture in 1969 to that in 1970?
Offer a terse response. 1.06. What is the ratio of the Value added (current US$) in Industry in 1969 to that in 1971?
Your answer should be very brief. 0.96. What is the ratio of the Value added (current US$) in Manufacturing in 1969 to that in 1971?
Your answer should be very brief. 0.74. What is the ratio of the Value added (current US$) in Services in 1969 to that in 1971?
Provide a short and direct response. 0.9. What is the ratio of the Value added (current US$) of Agriculture in 1969 to that in 1971?
Keep it short and to the point. 0.95. What is the ratio of the Value added (current US$) in Industry in 1969 to that in 1972?
Your answer should be very brief. 0.83. What is the ratio of the Value added (current US$) in Manufacturing in 1969 to that in 1972?
Provide a succinct answer. 0.59. What is the ratio of the Value added (current US$) of Services in 1969 to that in 1972?
Ensure brevity in your answer.  0.82. What is the ratio of the Value added (current US$) in Agriculture in 1969 to that in 1972?
Keep it short and to the point. 0.8. What is the ratio of the Value added (current US$) in Industry in 1969 to that in 1973?
Offer a terse response. 0.74. What is the ratio of the Value added (current US$) in Manufacturing in 1969 to that in 1973?
Offer a very short reply. 0.48. What is the ratio of the Value added (current US$) of Services in 1969 to that in 1973?
Offer a terse response. 0.72. What is the ratio of the Value added (current US$) in Agriculture in 1969 to that in 1973?
Your answer should be compact. 0.69. What is the ratio of the Value added (current US$) of Industry in 1969 to that in 1974?
Ensure brevity in your answer.  0.74. What is the ratio of the Value added (current US$) in Manufacturing in 1969 to that in 1974?
Offer a very short reply. 0.41. What is the ratio of the Value added (current US$) in Services in 1969 to that in 1974?
Make the answer very short. 0.54. What is the ratio of the Value added (current US$) in Agriculture in 1969 to that in 1974?
Provide a short and direct response. 0.58. What is the ratio of the Value added (current US$) in Industry in 1969 to that in 1975?
Ensure brevity in your answer.  0.58. What is the ratio of the Value added (current US$) in Manufacturing in 1969 to that in 1975?
Provide a succinct answer. 0.33. What is the ratio of the Value added (current US$) in Services in 1969 to that in 1975?
Make the answer very short. 0.42. What is the ratio of the Value added (current US$) in Agriculture in 1969 to that in 1975?
Ensure brevity in your answer.  0.48. What is the ratio of the Value added (current US$) in Industry in 1970 to that in 1971?
Offer a very short reply. 0.91. What is the ratio of the Value added (current US$) in Services in 1970 to that in 1971?
Make the answer very short. 1.01. What is the ratio of the Value added (current US$) of Agriculture in 1970 to that in 1971?
Give a very brief answer. 0.9. What is the ratio of the Value added (current US$) of Industry in 1970 to that in 1972?
Offer a very short reply. 0.79. What is the ratio of the Value added (current US$) of Manufacturing in 1970 to that in 1972?
Keep it short and to the point. 0.77. What is the ratio of the Value added (current US$) of Services in 1970 to that in 1972?
Your answer should be very brief. 0.93. What is the ratio of the Value added (current US$) of Agriculture in 1970 to that in 1972?
Provide a succinct answer. 0.76. What is the ratio of the Value added (current US$) in Industry in 1970 to that in 1973?
Offer a very short reply. 0.7. What is the ratio of the Value added (current US$) of Manufacturing in 1970 to that in 1973?
Provide a short and direct response. 0.63. What is the ratio of the Value added (current US$) in Services in 1970 to that in 1973?
Provide a succinct answer. 0.81. What is the ratio of the Value added (current US$) in Agriculture in 1970 to that in 1973?
Provide a succinct answer. 0.65. What is the ratio of the Value added (current US$) of Industry in 1970 to that in 1974?
Offer a terse response. 0.7. What is the ratio of the Value added (current US$) in Manufacturing in 1970 to that in 1974?
Offer a very short reply. 0.54. What is the ratio of the Value added (current US$) of Services in 1970 to that in 1974?
Ensure brevity in your answer.  0.61. What is the ratio of the Value added (current US$) of Agriculture in 1970 to that in 1974?
Give a very brief answer. 0.55. What is the ratio of the Value added (current US$) in Industry in 1970 to that in 1975?
Offer a terse response. 0.55. What is the ratio of the Value added (current US$) in Manufacturing in 1970 to that in 1975?
Your response must be concise. 0.44. What is the ratio of the Value added (current US$) in Services in 1970 to that in 1975?
Give a very brief answer. 0.47. What is the ratio of the Value added (current US$) in Agriculture in 1970 to that in 1975?
Keep it short and to the point. 0.45. What is the ratio of the Value added (current US$) in Industry in 1971 to that in 1972?
Make the answer very short. 0.86. What is the ratio of the Value added (current US$) in Manufacturing in 1971 to that in 1972?
Make the answer very short. 0.79. What is the ratio of the Value added (current US$) in Services in 1971 to that in 1972?
Provide a succinct answer. 0.92. What is the ratio of the Value added (current US$) of Agriculture in 1971 to that in 1972?
Your response must be concise. 0.85. What is the ratio of the Value added (current US$) of Industry in 1971 to that in 1973?
Offer a terse response. 0.76. What is the ratio of the Value added (current US$) in Manufacturing in 1971 to that in 1973?
Make the answer very short. 0.65. What is the ratio of the Value added (current US$) in Services in 1971 to that in 1973?
Make the answer very short. 0.8. What is the ratio of the Value added (current US$) in Agriculture in 1971 to that in 1973?
Your response must be concise. 0.72. What is the ratio of the Value added (current US$) in Industry in 1971 to that in 1974?
Provide a succinct answer. 0.77. What is the ratio of the Value added (current US$) of Manufacturing in 1971 to that in 1974?
Your answer should be compact. 0.55. What is the ratio of the Value added (current US$) of Services in 1971 to that in 1974?
Your response must be concise. 0.61. What is the ratio of the Value added (current US$) in Agriculture in 1971 to that in 1974?
Offer a terse response. 0.61. What is the ratio of the Value added (current US$) in Industry in 1971 to that in 1975?
Offer a very short reply. 0.6. What is the ratio of the Value added (current US$) of Manufacturing in 1971 to that in 1975?
Give a very brief answer. 0.45. What is the ratio of the Value added (current US$) of Services in 1971 to that in 1975?
Give a very brief answer. 0.46. What is the ratio of the Value added (current US$) of Agriculture in 1971 to that in 1975?
Ensure brevity in your answer.  0.5. What is the ratio of the Value added (current US$) of Industry in 1972 to that in 1973?
Your answer should be very brief. 0.88. What is the ratio of the Value added (current US$) in Manufacturing in 1972 to that in 1973?
Make the answer very short. 0.82. What is the ratio of the Value added (current US$) in Services in 1972 to that in 1973?
Offer a terse response. 0.87. What is the ratio of the Value added (current US$) in Agriculture in 1972 to that in 1973?
Offer a terse response. 0.85. What is the ratio of the Value added (current US$) in Industry in 1972 to that in 1974?
Provide a short and direct response. 0.89. What is the ratio of the Value added (current US$) in Manufacturing in 1972 to that in 1974?
Keep it short and to the point. 0.7. What is the ratio of the Value added (current US$) of Services in 1972 to that in 1974?
Your answer should be compact. 0.66. What is the ratio of the Value added (current US$) of Agriculture in 1972 to that in 1974?
Your answer should be compact. 0.72. What is the ratio of the Value added (current US$) in Industry in 1972 to that in 1975?
Make the answer very short. 0.69. What is the ratio of the Value added (current US$) of Manufacturing in 1972 to that in 1975?
Keep it short and to the point. 0.57. What is the ratio of the Value added (current US$) of Services in 1972 to that in 1975?
Keep it short and to the point. 0.51. What is the ratio of the Value added (current US$) of Agriculture in 1972 to that in 1975?
Provide a short and direct response. 0.59. What is the ratio of the Value added (current US$) of Industry in 1973 to that in 1974?
Your response must be concise. 1.01. What is the ratio of the Value added (current US$) of Manufacturing in 1973 to that in 1974?
Keep it short and to the point. 0.85. What is the ratio of the Value added (current US$) of Services in 1973 to that in 1974?
Your response must be concise. 0.76. What is the ratio of the Value added (current US$) in Agriculture in 1973 to that in 1974?
Make the answer very short. 0.84. What is the ratio of the Value added (current US$) of Industry in 1973 to that in 1975?
Your response must be concise. 0.78. What is the ratio of the Value added (current US$) in Manufacturing in 1973 to that in 1975?
Offer a terse response. 0.69. What is the ratio of the Value added (current US$) of Services in 1973 to that in 1975?
Provide a succinct answer. 0.58. What is the ratio of the Value added (current US$) in Agriculture in 1973 to that in 1975?
Your response must be concise. 0.69. What is the ratio of the Value added (current US$) in Industry in 1974 to that in 1975?
Ensure brevity in your answer.  0.78. What is the ratio of the Value added (current US$) of Manufacturing in 1974 to that in 1975?
Offer a terse response. 0.81. What is the ratio of the Value added (current US$) in Services in 1974 to that in 1975?
Make the answer very short. 0.76. What is the ratio of the Value added (current US$) of Agriculture in 1974 to that in 1975?
Offer a terse response. 0.83. What is the difference between the highest and the second highest Value added (current US$) of Industry?
Give a very brief answer. 1.75e+07. What is the difference between the highest and the second highest Value added (current US$) in Manufacturing?
Keep it short and to the point. 4.99e+06. What is the difference between the highest and the second highest Value added (current US$) of Services?
Give a very brief answer. 3.26e+07. What is the difference between the highest and the second highest Value added (current US$) in Agriculture?
Offer a very short reply. 2.29e+07. What is the difference between the highest and the lowest Value added (current US$) in Industry?
Ensure brevity in your answer.  3.66e+07. What is the difference between the highest and the lowest Value added (current US$) of Manufacturing?
Your answer should be very brief. 1.77e+07. What is the difference between the highest and the lowest Value added (current US$) of Services?
Provide a succinct answer. 8.09e+07. What is the difference between the highest and the lowest Value added (current US$) of Agriculture?
Give a very brief answer. 7.29e+07. 